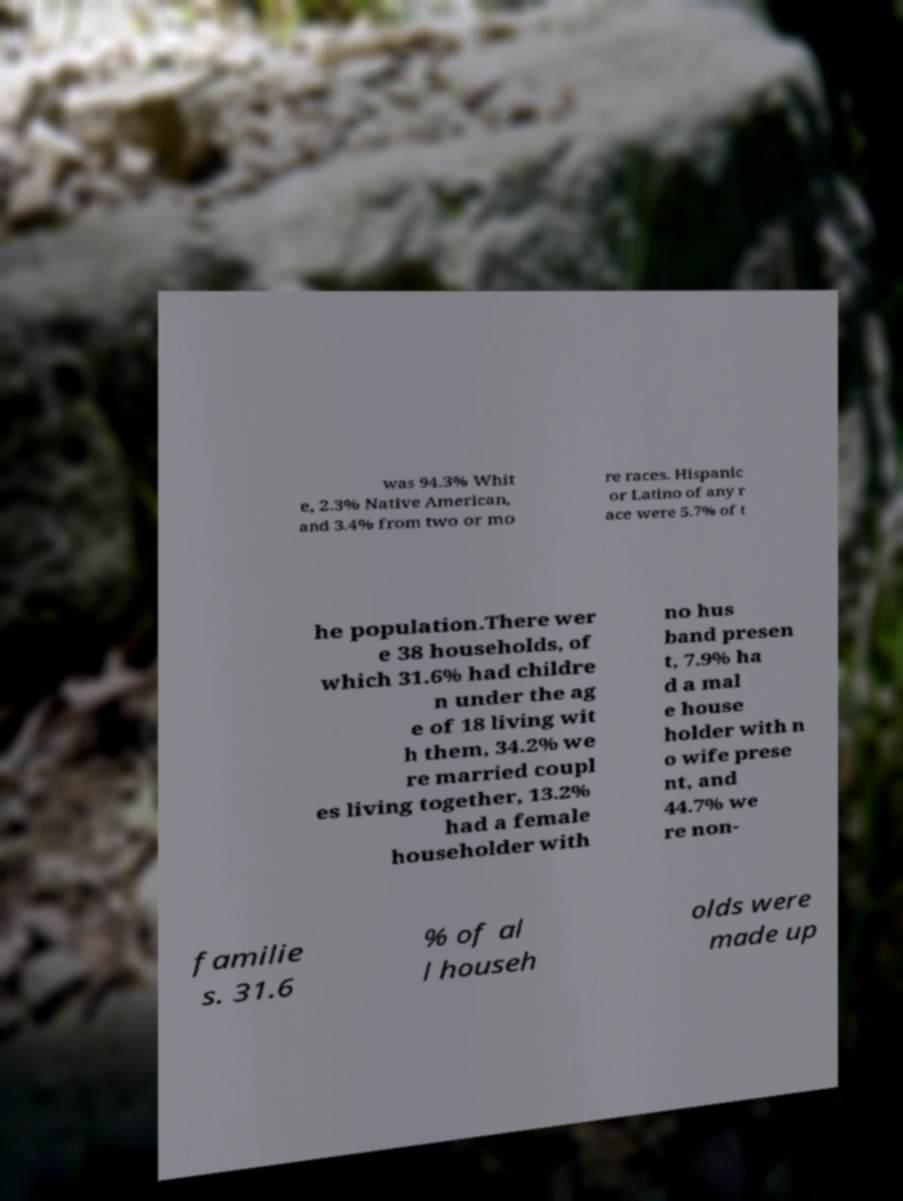What messages or text are displayed in this image? I need them in a readable, typed format. was 94.3% Whit e, 2.3% Native American, and 3.4% from two or mo re races. Hispanic or Latino of any r ace were 5.7% of t he population.There wer e 38 households, of which 31.6% had childre n under the ag e of 18 living wit h them, 34.2% we re married coupl es living together, 13.2% had a female householder with no hus band presen t, 7.9% ha d a mal e house holder with n o wife prese nt, and 44.7% we re non- familie s. 31.6 % of al l househ olds were made up 